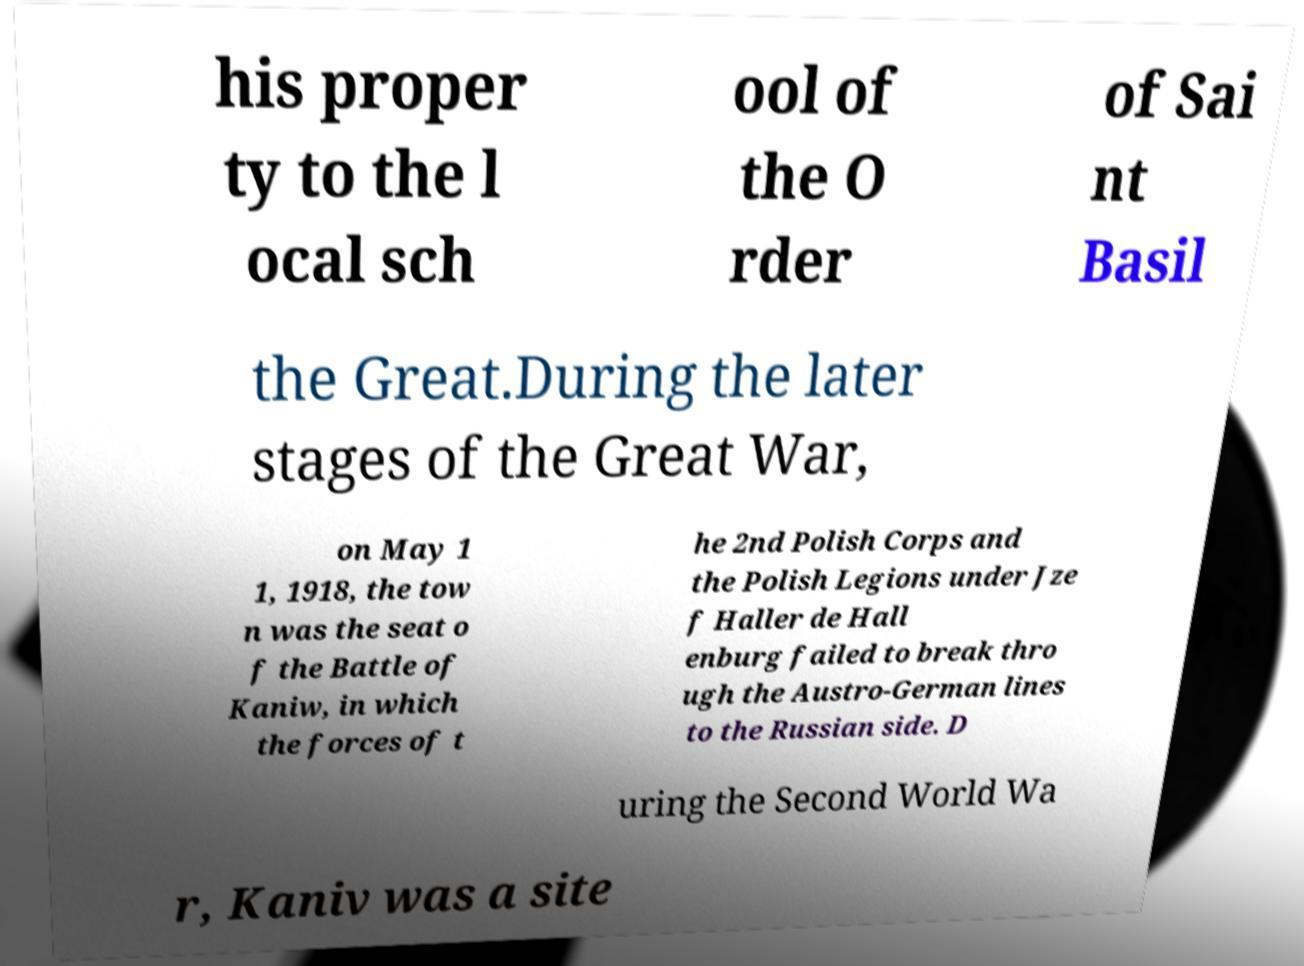Can you accurately transcribe the text from the provided image for me? his proper ty to the l ocal sch ool of the O rder of Sai nt Basil the Great.During the later stages of the Great War, on May 1 1, 1918, the tow n was the seat o f the Battle of Kaniw, in which the forces of t he 2nd Polish Corps and the Polish Legions under Jze f Haller de Hall enburg failed to break thro ugh the Austro-German lines to the Russian side. D uring the Second World Wa r, Kaniv was a site 